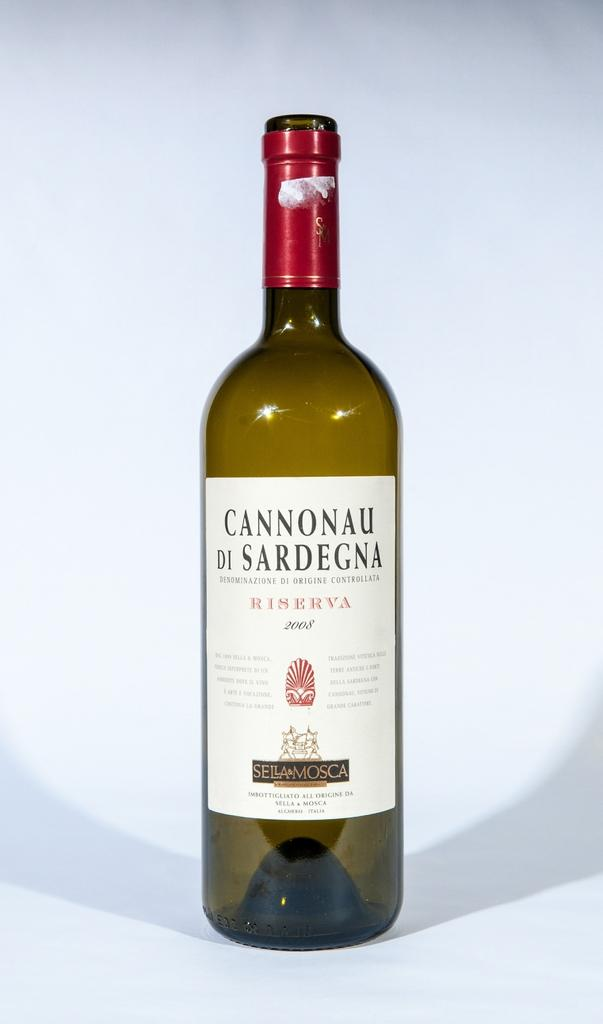<image>
Relay a brief, clear account of the picture shown. A bottle of wine is produced by Sella & Mosca. 